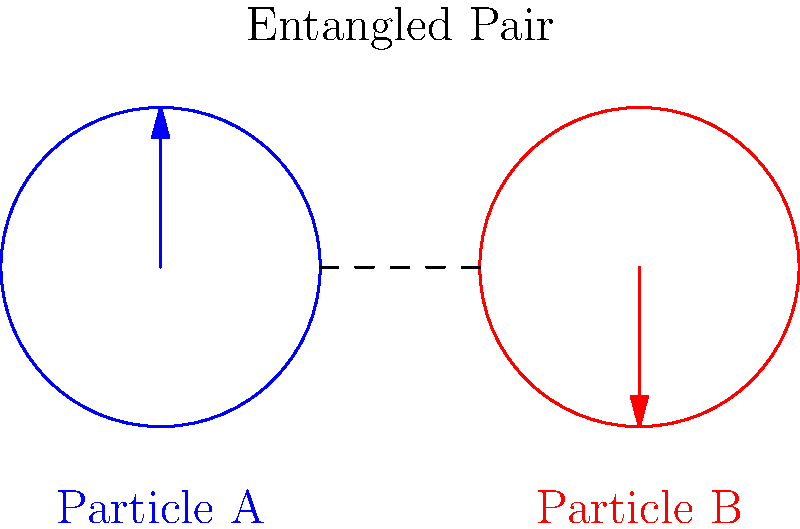In the context of quantum computing, explain how the diagram illustrates the concept of quantum entanglement and discuss its potential implications for data privacy legislation. 1. The diagram shows two particles, A and B, represented by blue and red circles.

2. The arrows indicate the spin states of the particles, with Particle A's spin pointing up and Particle B's spin pointing down.

3. The dashed line connecting the particles represents their entanglement, meaning their quantum states are correlated.

4. In quantum entanglement, measuring the state of one particle instantly determines the state of the other, regardless of distance.

5. This property challenges classical notions of locality and determinism, as information seems to travel faster than light.

6. For quantum computing, entanglement enables:
   a) Quantum parallelism, allowing multiple computations simultaneously
   b) Quantum cryptography, potentially unbreakable encryption methods

7. Data privacy implications:
   a) Quantum computers could break current encryption standards
   b) New legislation may be needed to address quantum-resistant cryptography
   c) Privacy laws may need updating to account for quantum computing capabilities

8. Potential areas for legislation:
   a) Mandating quantum-resistant encryption for sensitive data
   b) Regulating the development and use of quantum computers
   c) Establishing new standards for data protection in the quantum era

9. The challenge for lawmakers is to balance technological advancement with protecting individual privacy rights in a post-quantum world.
Answer: Quantum entanglement allows instantaneous correlation between particles, enabling powerful quantum computing capabilities that may require new data privacy legislation to address potential security risks and ensure adequate protection in the quantum era. 